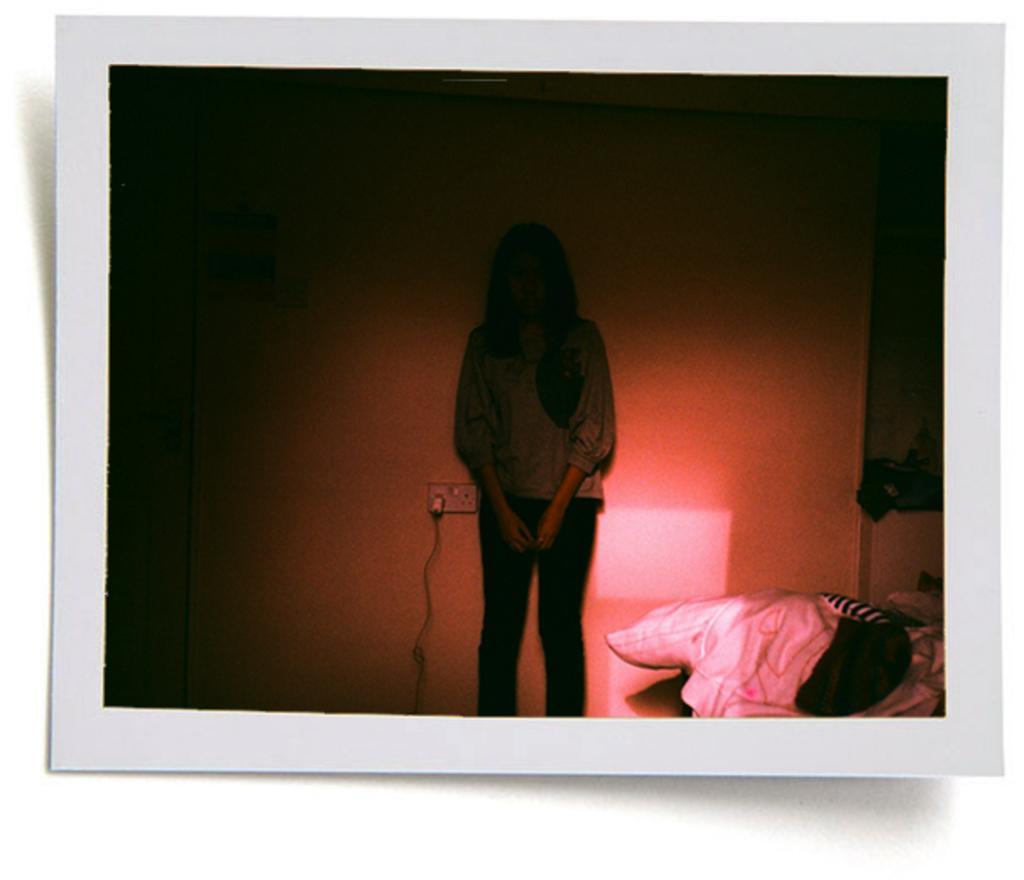Could you give a brief overview of what you see in this image? In this image I can see a person standing. Also I can see a lamp,wall,cable,socket and in the bottom right corner there are some objects. 